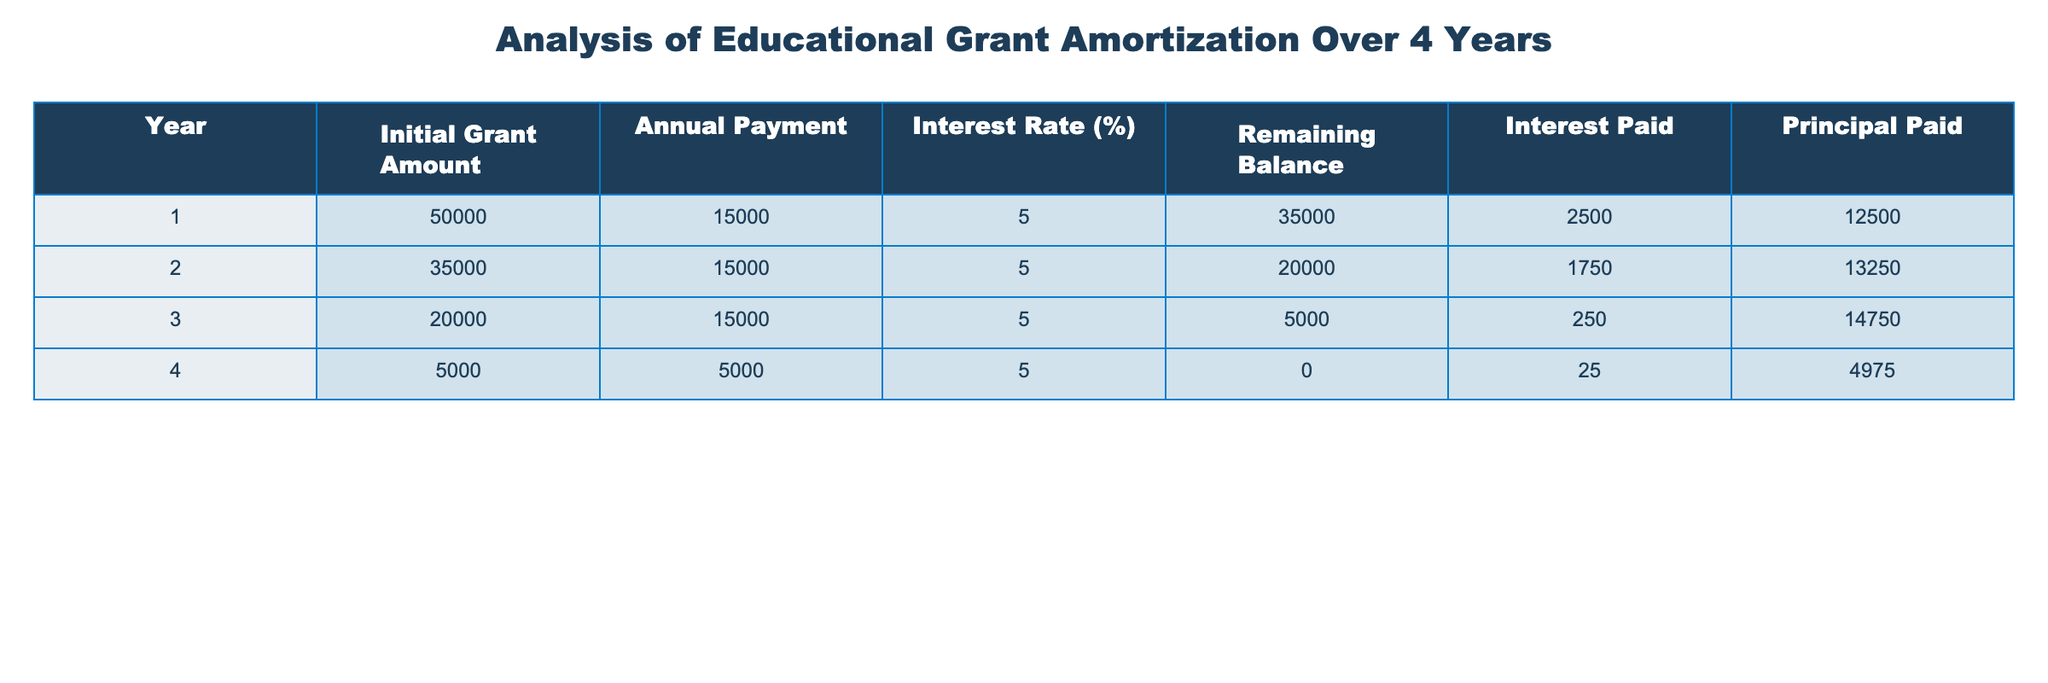What is the initial grant amount? The initial grant amount for year 1 is listed in the table, which shows 50,000.
Answer: 50000 What was the annual payment in year 3? According to the table, the annual payment for year 3 is 15,000 as specified in that row.
Answer: 15000 How much was the remaining balance after year 2? The remaining balance can be found in the year 2 row of the table, which states the balance is 20,000.
Answer: 20000 What is the total interest paid over the 4 years? To find the total interest paid, we add the interest from each year: 2500 + 1750 + 250 + 25 = 3525.
Answer: 3525 Is there a year when the principal paid was equal to the annual payment? In year 4, the principal paid is 4975 and the annual payment is also 5000, so they are not equal; thus the answer is no.
Answer: No What is the average principal paid over the 4 years? To find the average, we sum the principal paid each year: 12500 + 13250 + 14750 + 4975 = 45575, then divide by 4 which gives 11393.75.
Answer: 11393.75 In which year did the highest principal payment occur? From the principal paid column, year 3 has the highest payment of 14750 compared to other years.
Answer: Year 3 What was the difference in remaining balance from year 1 to year 2? The remaining balance in year 1 is 35000 and in year 2 is 20000. The difference is 35000 - 20000 = 15000.
Answer: 15000 Was the interest rate consistent for all four years? Observing the table, the interest rate is consistently 5% across all four years. Therefore, the answer is yes.
Answer: Yes 